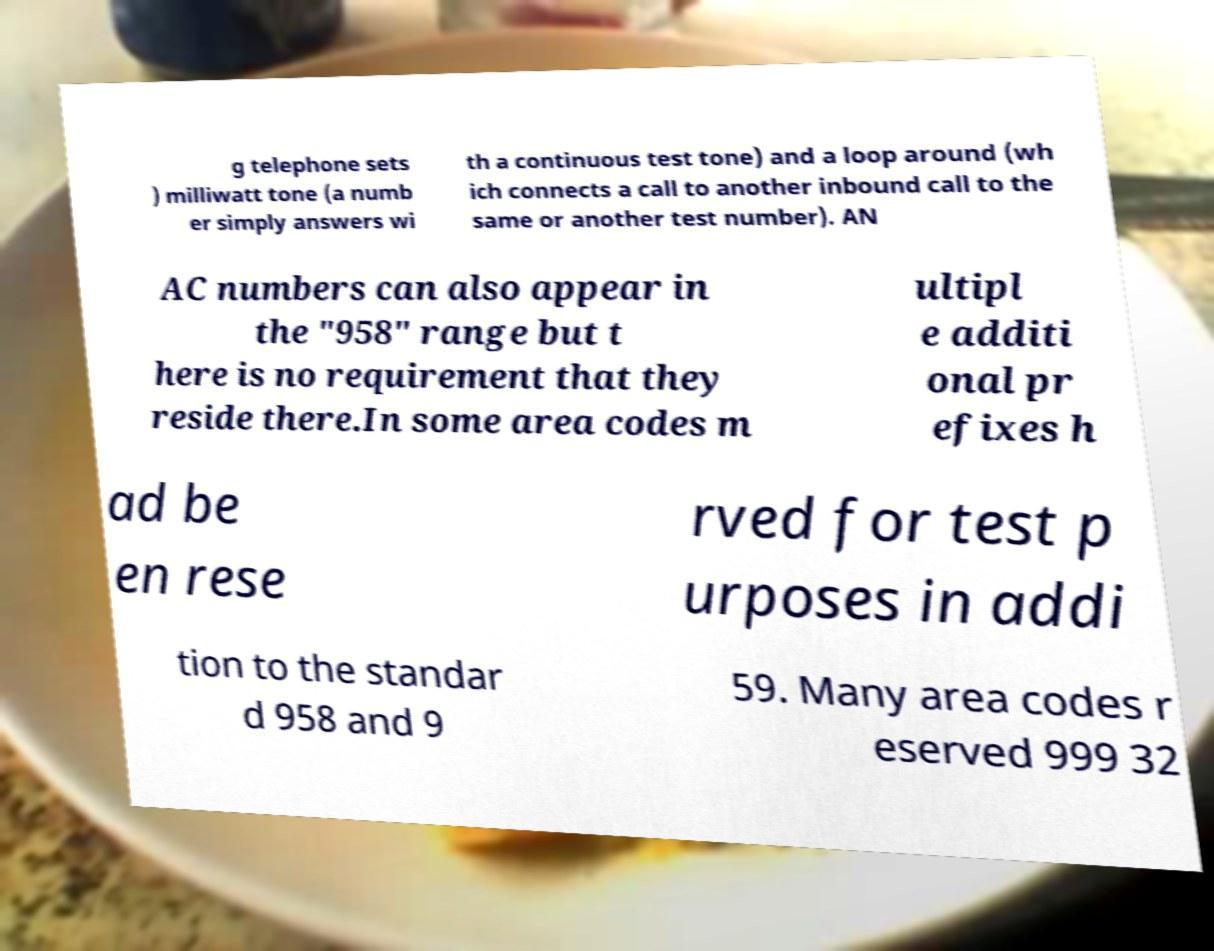There's text embedded in this image that I need extracted. Can you transcribe it verbatim? g telephone sets ) milliwatt tone (a numb er simply answers wi th a continuous test tone) and a loop around (wh ich connects a call to another inbound call to the same or another test number). AN AC numbers can also appear in the "958" range but t here is no requirement that they reside there.In some area codes m ultipl e additi onal pr efixes h ad be en rese rved for test p urposes in addi tion to the standar d 958 and 9 59. Many area codes r eserved 999 32 